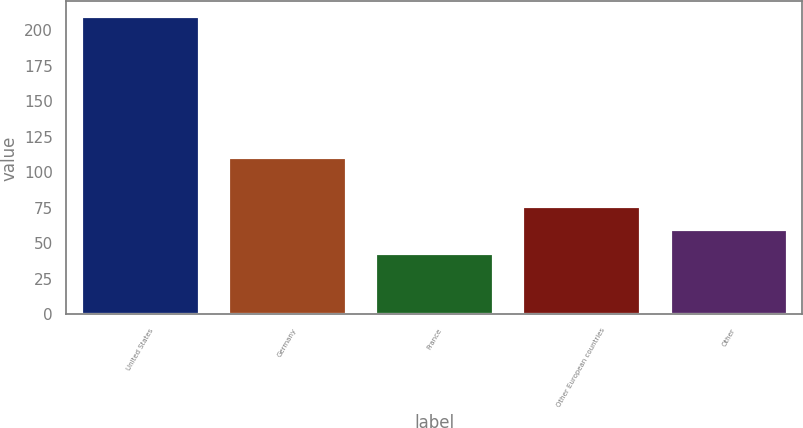Convert chart. <chart><loc_0><loc_0><loc_500><loc_500><bar_chart><fcel>United States<fcel>Germany<fcel>France<fcel>Other European countries<fcel>Other<nl><fcel>209.9<fcel>111<fcel>43.1<fcel>76.46<fcel>59.78<nl></chart> 